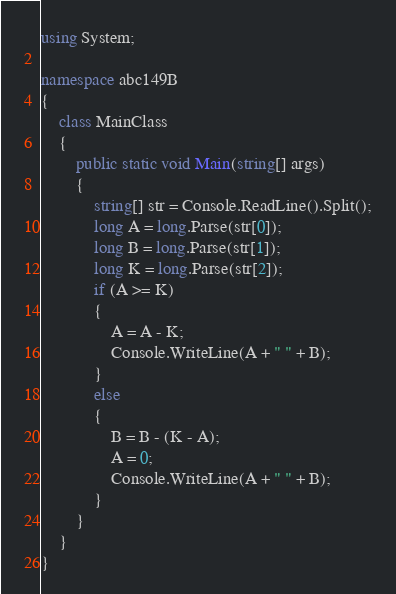<code> <loc_0><loc_0><loc_500><loc_500><_C#_>using System;

namespace abc149B
{
    class MainClass
    {
        public static void Main(string[] args)
        {
            string[] str = Console.ReadLine().Split();
            long A = long.Parse(str[0]);
            long B = long.Parse(str[1]);
            long K = long.Parse(str[2]);
            if (A >= K)
            {
                A = A - K;
                Console.WriteLine(A + " " + B);
            }
            else
            {
                B = B - (K - A);
                A = 0;
                Console.WriteLine(A + " " + B);
            }
        }
    }
}
</code> 